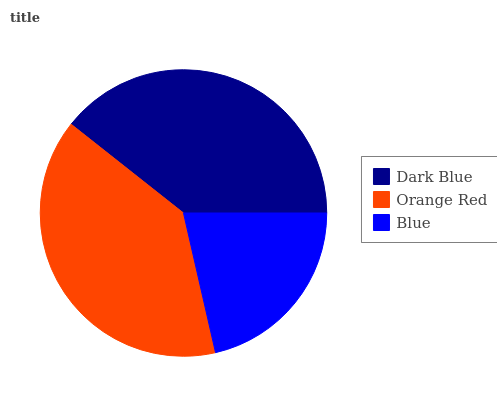Is Blue the minimum?
Answer yes or no. Yes. Is Dark Blue the maximum?
Answer yes or no. Yes. Is Orange Red the minimum?
Answer yes or no. No. Is Orange Red the maximum?
Answer yes or no. No. Is Dark Blue greater than Orange Red?
Answer yes or no. Yes. Is Orange Red less than Dark Blue?
Answer yes or no. Yes. Is Orange Red greater than Dark Blue?
Answer yes or no. No. Is Dark Blue less than Orange Red?
Answer yes or no. No. Is Orange Red the high median?
Answer yes or no. Yes. Is Orange Red the low median?
Answer yes or no. Yes. Is Blue the high median?
Answer yes or no. No. Is Dark Blue the low median?
Answer yes or no. No. 